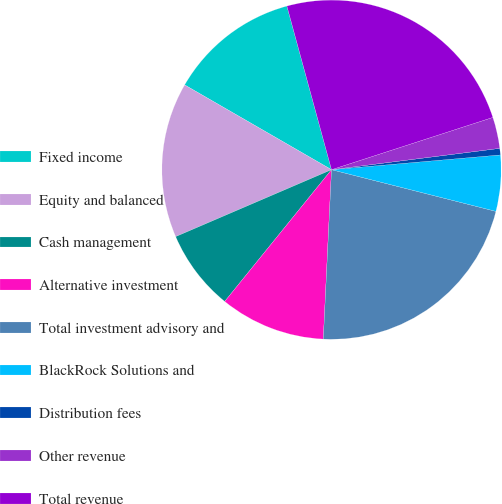<chart> <loc_0><loc_0><loc_500><loc_500><pie_chart><fcel>Fixed income<fcel>Equity and balanced<fcel>Cash management<fcel>Alternative investment<fcel>Total investment advisory and<fcel>BlackRock Solutions and<fcel>Distribution fees<fcel>Other revenue<fcel>Total revenue<nl><fcel>12.43%<fcel>14.79%<fcel>7.7%<fcel>10.07%<fcel>21.82%<fcel>5.34%<fcel>0.62%<fcel>2.98%<fcel>24.25%<nl></chart> 